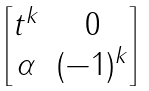<formula> <loc_0><loc_0><loc_500><loc_500>\begin{bmatrix} t ^ { k } & 0 \\ \alpha & ( - 1 ) ^ { k } \end{bmatrix}</formula> 